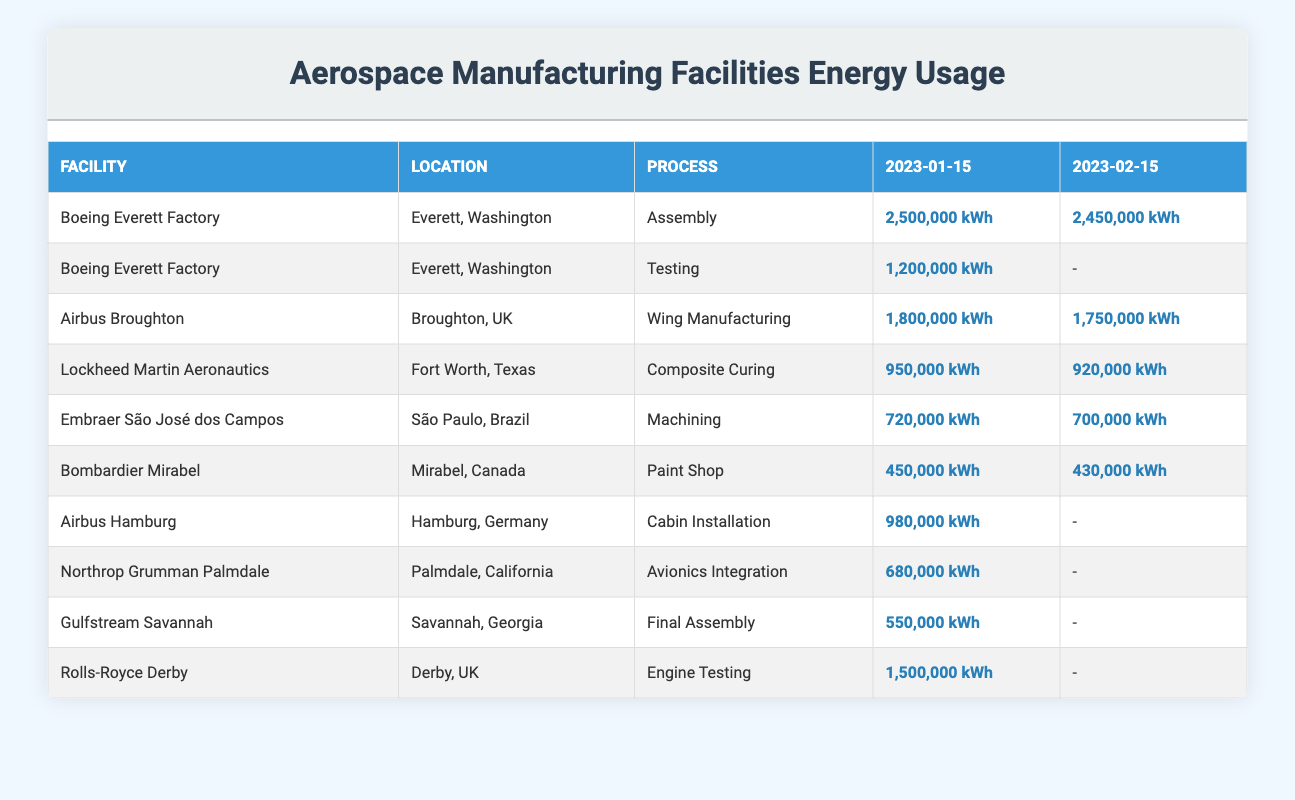What is the energy usage for Assembly at the Boeing Everett Factory on January 15, 2023? The table shows that the energy usage for Assembly at the Boeing Everett Factory on January 15, 2023 is 2,500,000 kWh.
Answer: 2,500,000 kWh How much energy did Airbus Broughton use for Wing Manufacturing in February 2023? The table indicates that Airbus Broughton used 1,750,000 kWh for Wing Manufacturing on February 15, 2023.
Answer: 1,750,000 kWh Is the energy used for Testing at the Boeing Everett Factory the same as the energy used for Composite Curing at Lockheed Martin Aeronautics on January 15, 2023? The energy used for Testing at the Boeing Everett Factory is 1,200,000 kWh, while the energy used for Composite Curing at Lockheed Martin Aeronautics is 950,000 kWh. Since these values are different, the answer is no.
Answer: No What is the total energy usage for all processes at the Bombardier Mirabel facility on January 15, 2023? The only process listed for Bombardier Mirabel on January 15, 2023, is the Paint Shop, which shows an energy usage of 450,000 kWh. Therefore, the total energy usage is just that amount.
Answer: 450,000 kWh What process at the Boeing Everett Factory had the highest energy usage in January 2023? The table indicates that the Assembly process had the highest energy usage at the Boeing Everett Factory in January 2023, using 2,500,000 kWh.
Answer: Assembly What was the increase in energy usage for Wing Manufacturing at Airbus Broughton from January to February 2023? In January 2023, the energy usage for Wing Manufacturing at Airbus Broughton was 1,800,000 kWh and in February it was 1,750,000 kWh. The increase is calculated as 1,750,000 - 1,800,000 = -50,000 kWh, indicating a decrease.
Answer: Decrease of 50,000 kWh Did the energy usage for Composite Curing at Lockheed Martin Aeronautics decrease from January to February 2023? The January energy usage for Composite Curing was 950,000 kWh and for February it was 920,000 kWh, showing a decrease from January to February. Therefore, the answer is yes.
Answer: Yes Which facility had the lowest energy usage across all processes listed for January 2023? By comparing the energy usage across all processes, Bombardier Mirabel with its Paint Shop usage of 450,000 kWh had the lowest energy usage listed among the facilities for January 2023.
Answer: Bombardier Mirabel What is the average energy usage across all processes at the Boeing Everett Factory for January 2023? The Boeing Everett Factory had two processes listed: Assembly (2,500,000 kWh) and Testing (1,200,000 kWh). The average energy usage is (2,500,000 + 1,200,000) / 2 = 1,850,000 kWh.
Answer: 1,850,000 kWh 